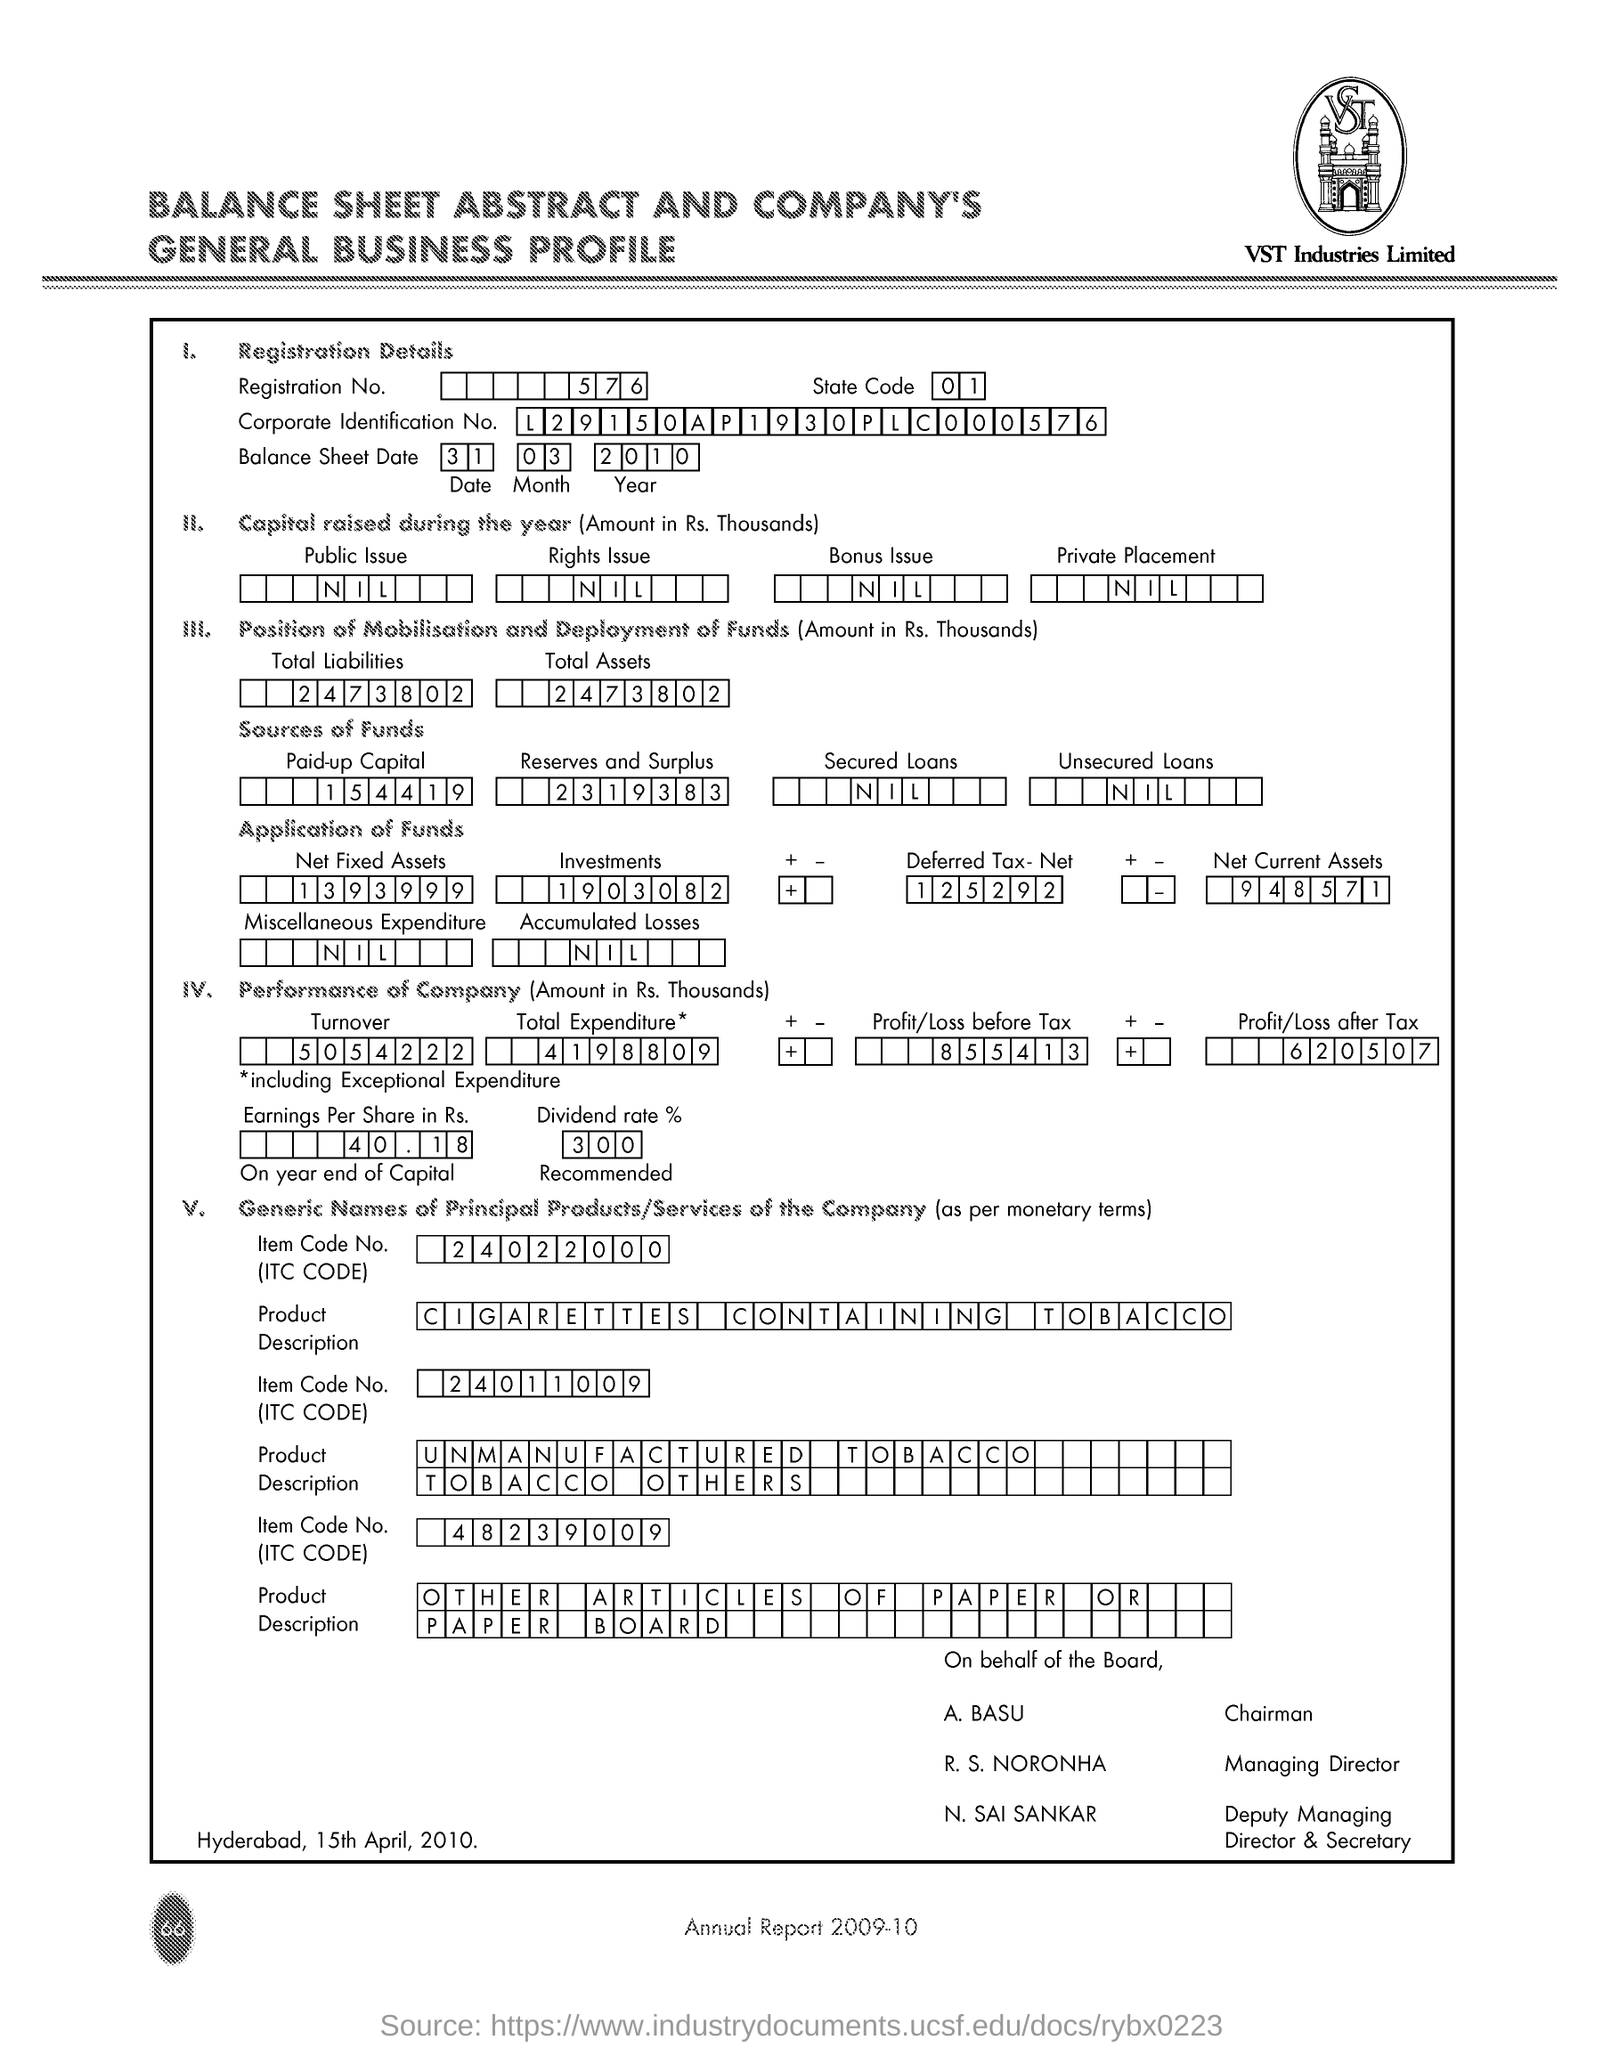What is registration No.?
Give a very brief answer. 5 7 6. What is state code?
Give a very brief answer. 01. What is balance sheet date?
Your answer should be very brief. 31 . 03 . 2010. What is total liability?
Your answer should be very brief. 2 4 7 3 8 0 2. What is total Assets?
Provide a short and direct response. 2 4 7 3 8 0 2. What is paid up capital?
Provide a succinct answer. 1 5 4 4 1 9. What is secured loan?
Keep it short and to the point. NIL. What is unsecured loan?
Offer a very short reply. N I L. 